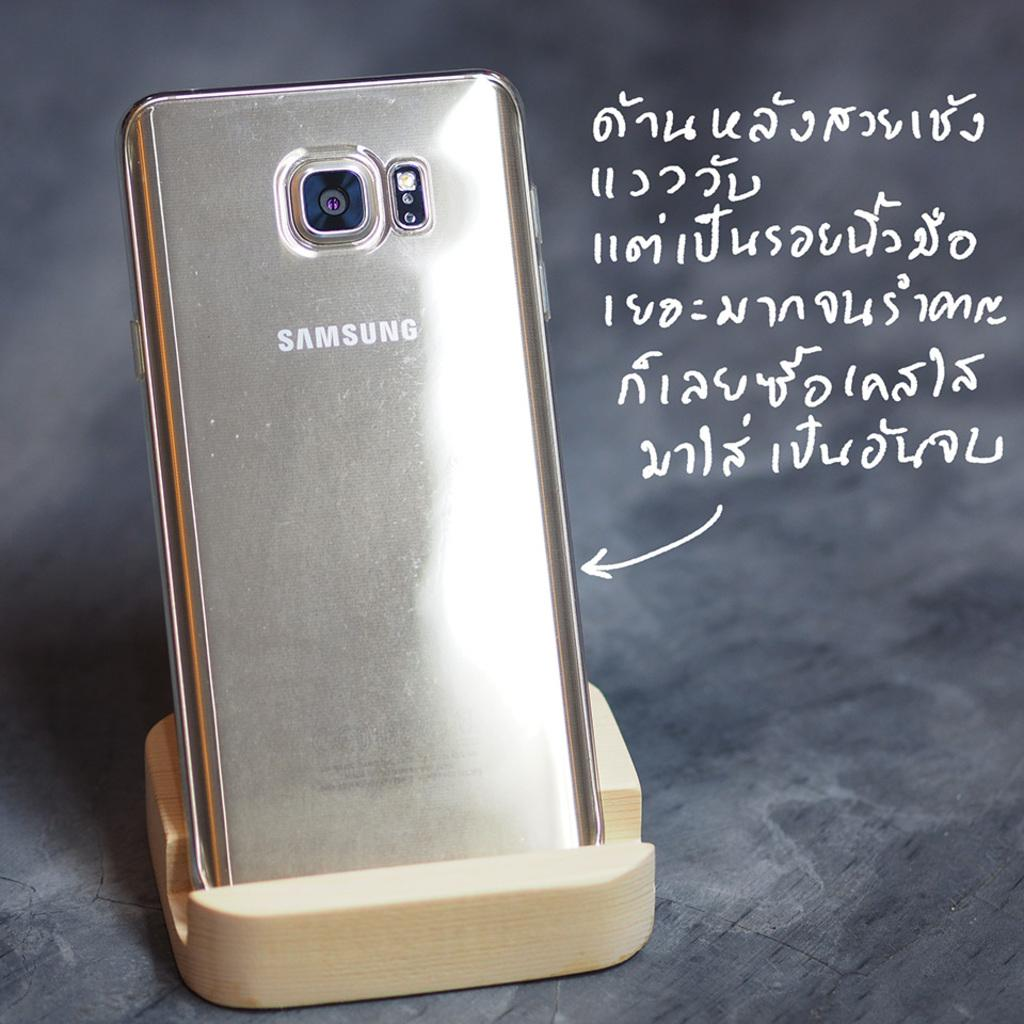<image>
Give a short and clear explanation of the subsequent image. A samsung phone sitting on a wood stand 